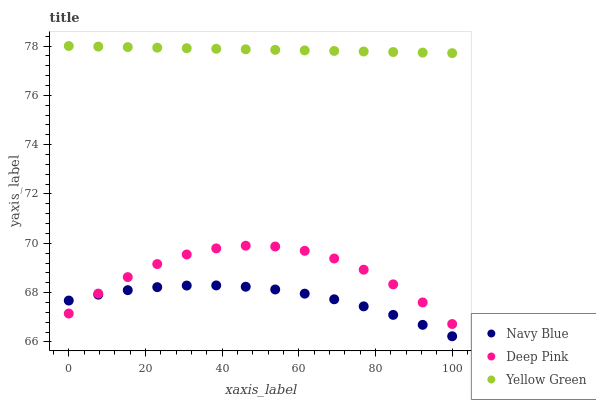Does Navy Blue have the minimum area under the curve?
Answer yes or no. Yes. Does Yellow Green have the maximum area under the curve?
Answer yes or no. Yes. Does Deep Pink have the minimum area under the curve?
Answer yes or no. No. Does Deep Pink have the maximum area under the curve?
Answer yes or no. No. Is Yellow Green the smoothest?
Answer yes or no. Yes. Is Deep Pink the roughest?
Answer yes or no. Yes. Is Deep Pink the smoothest?
Answer yes or no. No. Is Yellow Green the roughest?
Answer yes or no. No. Does Navy Blue have the lowest value?
Answer yes or no. Yes. Does Deep Pink have the lowest value?
Answer yes or no. No. Does Yellow Green have the highest value?
Answer yes or no. Yes. Does Deep Pink have the highest value?
Answer yes or no. No. Is Deep Pink less than Yellow Green?
Answer yes or no. Yes. Is Yellow Green greater than Navy Blue?
Answer yes or no. Yes. Does Navy Blue intersect Deep Pink?
Answer yes or no. Yes. Is Navy Blue less than Deep Pink?
Answer yes or no. No. Is Navy Blue greater than Deep Pink?
Answer yes or no. No. Does Deep Pink intersect Yellow Green?
Answer yes or no. No. 